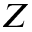Convert formula to latex. <formula><loc_0><loc_0><loc_500><loc_500>Z</formula> 